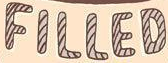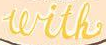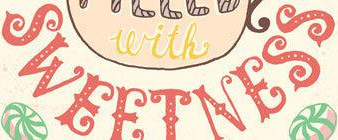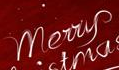Read the text content from these images in order, separated by a semicolon. FILLED; with; SWEETNESS; Merry 